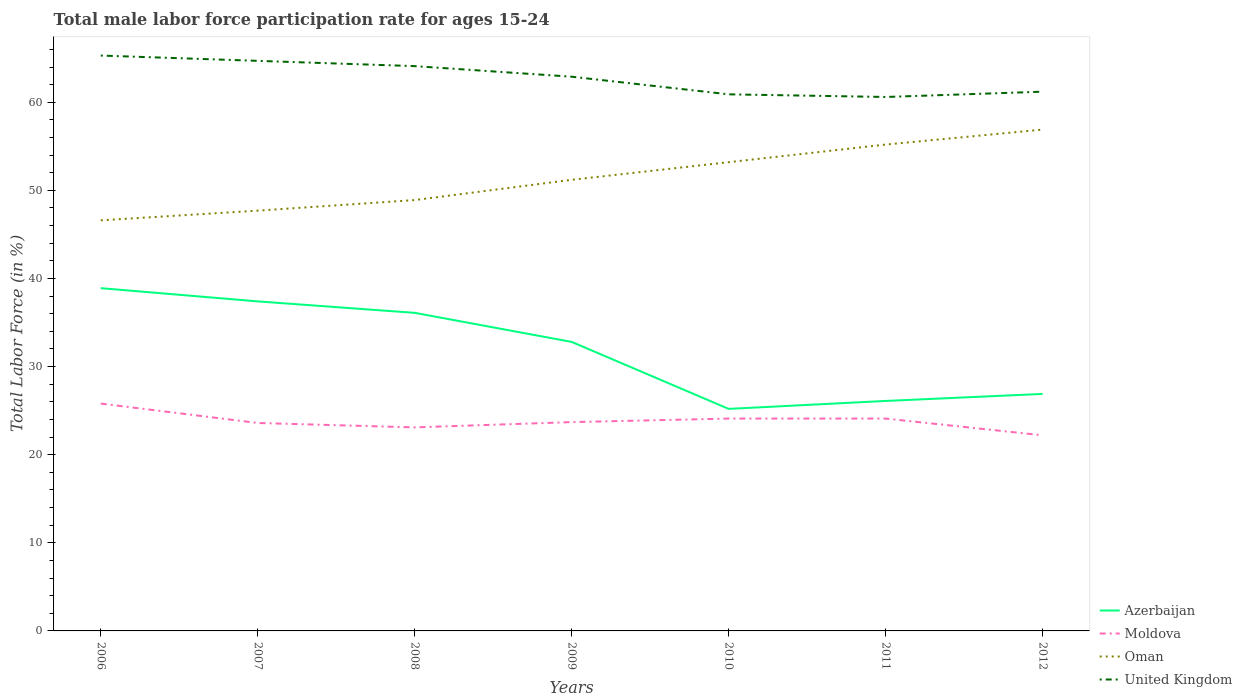How many different coloured lines are there?
Offer a terse response. 4. Does the line corresponding to Oman intersect with the line corresponding to United Kingdom?
Your response must be concise. No. Is the number of lines equal to the number of legend labels?
Offer a very short reply. Yes. Across all years, what is the maximum male labor force participation rate in Moldova?
Give a very brief answer. 22.2. What is the total male labor force participation rate in United Kingdom in the graph?
Offer a terse response. -0.6. What is the difference between the highest and the second highest male labor force participation rate in Oman?
Your answer should be very brief. 10.3. Is the male labor force participation rate in Moldova strictly greater than the male labor force participation rate in United Kingdom over the years?
Ensure brevity in your answer.  Yes. How many lines are there?
Provide a succinct answer. 4. What is the difference between two consecutive major ticks on the Y-axis?
Provide a succinct answer. 10. Does the graph contain any zero values?
Provide a short and direct response. No. Does the graph contain grids?
Keep it short and to the point. No. What is the title of the graph?
Provide a short and direct response. Total male labor force participation rate for ages 15-24. What is the Total Labor Force (in %) of Azerbaijan in 2006?
Ensure brevity in your answer.  38.9. What is the Total Labor Force (in %) of Moldova in 2006?
Make the answer very short. 25.8. What is the Total Labor Force (in %) in Oman in 2006?
Keep it short and to the point. 46.6. What is the Total Labor Force (in %) of United Kingdom in 2006?
Your answer should be compact. 65.3. What is the Total Labor Force (in %) in Azerbaijan in 2007?
Your answer should be compact. 37.4. What is the Total Labor Force (in %) in Moldova in 2007?
Make the answer very short. 23.6. What is the Total Labor Force (in %) in Oman in 2007?
Keep it short and to the point. 47.7. What is the Total Labor Force (in %) in United Kingdom in 2007?
Keep it short and to the point. 64.7. What is the Total Labor Force (in %) in Azerbaijan in 2008?
Your answer should be compact. 36.1. What is the Total Labor Force (in %) of Moldova in 2008?
Ensure brevity in your answer.  23.1. What is the Total Labor Force (in %) of Oman in 2008?
Keep it short and to the point. 48.9. What is the Total Labor Force (in %) in United Kingdom in 2008?
Offer a terse response. 64.1. What is the Total Labor Force (in %) in Azerbaijan in 2009?
Offer a very short reply. 32.8. What is the Total Labor Force (in %) in Moldova in 2009?
Give a very brief answer. 23.7. What is the Total Labor Force (in %) in Oman in 2009?
Provide a short and direct response. 51.2. What is the Total Labor Force (in %) of United Kingdom in 2009?
Keep it short and to the point. 62.9. What is the Total Labor Force (in %) of Azerbaijan in 2010?
Your response must be concise. 25.2. What is the Total Labor Force (in %) of Moldova in 2010?
Offer a terse response. 24.1. What is the Total Labor Force (in %) in Oman in 2010?
Keep it short and to the point. 53.2. What is the Total Labor Force (in %) in United Kingdom in 2010?
Offer a terse response. 60.9. What is the Total Labor Force (in %) of Azerbaijan in 2011?
Give a very brief answer. 26.1. What is the Total Labor Force (in %) of Moldova in 2011?
Make the answer very short. 24.1. What is the Total Labor Force (in %) of Oman in 2011?
Offer a terse response. 55.2. What is the Total Labor Force (in %) of United Kingdom in 2011?
Make the answer very short. 60.6. What is the Total Labor Force (in %) of Azerbaijan in 2012?
Keep it short and to the point. 26.9. What is the Total Labor Force (in %) in Moldova in 2012?
Keep it short and to the point. 22.2. What is the Total Labor Force (in %) in Oman in 2012?
Provide a short and direct response. 56.9. What is the Total Labor Force (in %) of United Kingdom in 2012?
Your answer should be very brief. 61.2. Across all years, what is the maximum Total Labor Force (in %) of Azerbaijan?
Offer a very short reply. 38.9. Across all years, what is the maximum Total Labor Force (in %) in Moldova?
Ensure brevity in your answer.  25.8. Across all years, what is the maximum Total Labor Force (in %) in Oman?
Keep it short and to the point. 56.9. Across all years, what is the maximum Total Labor Force (in %) in United Kingdom?
Ensure brevity in your answer.  65.3. Across all years, what is the minimum Total Labor Force (in %) in Azerbaijan?
Give a very brief answer. 25.2. Across all years, what is the minimum Total Labor Force (in %) of Moldova?
Ensure brevity in your answer.  22.2. Across all years, what is the minimum Total Labor Force (in %) of Oman?
Provide a succinct answer. 46.6. Across all years, what is the minimum Total Labor Force (in %) in United Kingdom?
Provide a short and direct response. 60.6. What is the total Total Labor Force (in %) of Azerbaijan in the graph?
Provide a succinct answer. 223.4. What is the total Total Labor Force (in %) in Moldova in the graph?
Give a very brief answer. 166.6. What is the total Total Labor Force (in %) of Oman in the graph?
Make the answer very short. 359.7. What is the total Total Labor Force (in %) in United Kingdom in the graph?
Your answer should be very brief. 439.7. What is the difference between the Total Labor Force (in %) of Azerbaijan in 2006 and that in 2007?
Offer a terse response. 1.5. What is the difference between the Total Labor Force (in %) in Moldova in 2006 and that in 2007?
Provide a succinct answer. 2.2. What is the difference between the Total Labor Force (in %) in Oman in 2006 and that in 2007?
Your response must be concise. -1.1. What is the difference between the Total Labor Force (in %) of United Kingdom in 2006 and that in 2007?
Your answer should be compact. 0.6. What is the difference between the Total Labor Force (in %) in Moldova in 2006 and that in 2008?
Your response must be concise. 2.7. What is the difference between the Total Labor Force (in %) in Oman in 2006 and that in 2008?
Your answer should be compact. -2.3. What is the difference between the Total Labor Force (in %) of Moldova in 2006 and that in 2009?
Your answer should be compact. 2.1. What is the difference between the Total Labor Force (in %) of Oman in 2006 and that in 2009?
Offer a very short reply. -4.6. What is the difference between the Total Labor Force (in %) in United Kingdom in 2006 and that in 2009?
Give a very brief answer. 2.4. What is the difference between the Total Labor Force (in %) in Azerbaijan in 2006 and that in 2010?
Give a very brief answer. 13.7. What is the difference between the Total Labor Force (in %) of Moldova in 2006 and that in 2010?
Offer a terse response. 1.7. What is the difference between the Total Labor Force (in %) of Oman in 2006 and that in 2011?
Offer a very short reply. -8.6. What is the difference between the Total Labor Force (in %) of Azerbaijan in 2006 and that in 2012?
Make the answer very short. 12. What is the difference between the Total Labor Force (in %) of Moldova in 2006 and that in 2012?
Your answer should be compact. 3.6. What is the difference between the Total Labor Force (in %) in Moldova in 2007 and that in 2008?
Offer a very short reply. 0.5. What is the difference between the Total Labor Force (in %) of United Kingdom in 2007 and that in 2008?
Keep it short and to the point. 0.6. What is the difference between the Total Labor Force (in %) of Oman in 2007 and that in 2009?
Keep it short and to the point. -3.5. What is the difference between the Total Labor Force (in %) of United Kingdom in 2007 and that in 2009?
Keep it short and to the point. 1.8. What is the difference between the Total Labor Force (in %) in United Kingdom in 2007 and that in 2010?
Provide a short and direct response. 3.8. What is the difference between the Total Labor Force (in %) of Oman in 2007 and that in 2011?
Make the answer very short. -7.5. What is the difference between the Total Labor Force (in %) of Oman in 2007 and that in 2012?
Provide a succinct answer. -9.2. What is the difference between the Total Labor Force (in %) of Oman in 2008 and that in 2009?
Offer a very short reply. -2.3. What is the difference between the Total Labor Force (in %) of United Kingdom in 2008 and that in 2010?
Keep it short and to the point. 3.2. What is the difference between the Total Labor Force (in %) of Azerbaijan in 2008 and that in 2011?
Make the answer very short. 10. What is the difference between the Total Labor Force (in %) of United Kingdom in 2008 and that in 2011?
Offer a very short reply. 3.5. What is the difference between the Total Labor Force (in %) of Azerbaijan in 2009 and that in 2010?
Keep it short and to the point. 7.6. What is the difference between the Total Labor Force (in %) of Moldova in 2009 and that in 2010?
Make the answer very short. -0.4. What is the difference between the Total Labor Force (in %) in Azerbaijan in 2009 and that in 2011?
Keep it short and to the point. 6.7. What is the difference between the Total Labor Force (in %) in Oman in 2009 and that in 2011?
Keep it short and to the point. -4. What is the difference between the Total Labor Force (in %) in Oman in 2009 and that in 2012?
Your response must be concise. -5.7. What is the difference between the Total Labor Force (in %) of United Kingdom in 2009 and that in 2012?
Provide a short and direct response. 1.7. What is the difference between the Total Labor Force (in %) of Moldova in 2010 and that in 2011?
Provide a succinct answer. 0. What is the difference between the Total Labor Force (in %) of Oman in 2010 and that in 2011?
Offer a very short reply. -2. What is the difference between the Total Labor Force (in %) in United Kingdom in 2010 and that in 2011?
Make the answer very short. 0.3. What is the difference between the Total Labor Force (in %) in United Kingdom in 2010 and that in 2012?
Provide a short and direct response. -0.3. What is the difference between the Total Labor Force (in %) in Moldova in 2011 and that in 2012?
Your answer should be compact. 1.9. What is the difference between the Total Labor Force (in %) of Azerbaijan in 2006 and the Total Labor Force (in %) of Moldova in 2007?
Your response must be concise. 15.3. What is the difference between the Total Labor Force (in %) of Azerbaijan in 2006 and the Total Labor Force (in %) of United Kingdom in 2007?
Make the answer very short. -25.8. What is the difference between the Total Labor Force (in %) in Moldova in 2006 and the Total Labor Force (in %) in Oman in 2007?
Your response must be concise. -21.9. What is the difference between the Total Labor Force (in %) of Moldova in 2006 and the Total Labor Force (in %) of United Kingdom in 2007?
Provide a succinct answer. -38.9. What is the difference between the Total Labor Force (in %) in Oman in 2006 and the Total Labor Force (in %) in United Kingdom in 2007?
Provide a succinct answer. -18.1. What is the difference between the Total Labor Force (in %) in Azerbaijan in 2006 and the Total Labor Force (in %) in Moldova in 2008?
Your answer should be compact. 15.8. What is the difference between the Total Labor Force (in %) in Azerbaijan in 2006 and the Total Labor Force (in %) in Oman in 2008?
Ensure brevity in your answer.  -10. What is the difference between the Total Labor Force (in %) in Azerbaijan in 2006 and the Total Labor Force (in %) in United Kingdom in 2008?
Your answer should be compact. -25.2. What is the difference between the Total Labor Force (in %) in Moldova in 2006 and the Total Labor Force (in %) in Oman in 2008?
Offer a very short reply. -23.1. What is the difference between the Total Labor Force (in %) of Moldova in 2006 and the Total Labor Force (in %) of United Kingdom in 2008?
Offer a very short reply. -38.3. What is the difference between the Total Labor Force (in %) in Oman in 2006 and the Total Labor Force (in %) in United Kingdom in 2008?
Make the answer very short. -17.5. What is the difference between the Total Labor Force (in %) of Azerbaijan in 2006 and the Total Labor Force (in %) of Moldova in 2009?
Your answer should be very brief. 15.2. What is the difference between the Total Labor Force (in %) in Azerbaijan in 2006 and the Total Labor Force (in %) in United Kingdom in 2009?
Offer a very short reply. -24. What is the difference between the Total Labor Force (in %) of Moldova in 2006 and the Total Labor Force (in %) of Oman in 2009?
Give a very brief answer. -25.4. What is the difference between the Total Labor Force (in %) of Moldova in 2006 and the Total Labor Force (in %) of United Kingdom in 2009?
Ensure brevity in your answer.  -37.1. What is the difference between the Total Labor Force (in %) of Oman in 2006 and the Total Labor Force (in %) of United Kingdom in 2009?
Your answer should be very brief. -16.3. What is the difference between the Total Labor Force (in %) of Azerbaijan in 2006 and the Total Labor Force (in %) of Moldova in 2010?
Keep it short and to the point. 14.8. What is the difference between the Total Labor Force (in %) of Azerbaijan in 2006 and the Total Labor Force (in %) of Oman in 2010?
Offer a terse response. -14.3. What is the difference between the Total Labor Force (in %) of Moldova in 2006 and the Total Labor Force (in %) of Oman in 2010?
Offer a very short reply. -27.4. What is the difference between the Total Labor Force (in %) of Moldova in 2006 and the Total Labor Force (in %) of United Kingdom in 2010?
Provide a succinct answer. -35.1. What is the difference between the Total Labor Force (in %) of Oman in 2006 and the Total Labor Force (in %) of United Kingdom in 2010?
Provide a succinct answer. -14.3. What is the difference between the Total Labor Force (in %) of Azerbaijan in 2006 and the Total Labor Force (in %) of Moldova in 2011?
Make the answer very short. 14.8. What is the difference between the Total Labor Force (in %) in Azerbaijan in 2006 and the Total Labor Force (in %) in Oman in 2011?
Give a very brief answer. -16.3. What is the difference between the Total Labor Force (in %) in Azerbaijan in 2006 and the Total Labor Force (in %) in United Kingdom in 2011?
Your response must be concise. -21.7. What is the difference between the Total Labor Force (in %) of Moldova in 2006 and the Total Labor Force (in %) of Oman in 2011?
Offer a very short reply. -29.4. What is the difference between the Total Labor Force (in %) of Moldova in 2006 and the Total Labor Force (in %) of United Kingdom in 2011?
Make the answer very short. -34.8. What is the difference between the Total Labor Force (in %) of Oman in 2006 and the Total Labor Force (in %) of United Kingdom in 2011?
Your answer should be very brief. -14. What is the difference between the Total Labor Force (in %) of Azerbaijan in 2006 and the Total Labor Force (in %) of United Kingdom in 2012?
Your response must be concise. -22.3. What is the difference between the Total Labor Force (in %) of Moldova in 2006 and the Total Labor Force (in %) of Oman in 2012?
Provide a succinct answer. -31.1. What is the difference between the Total Labor Force (in %) of Moldova in 2006 and the Total Labor Force (in %) of United Kingdom in 2012?
Provide a short and direct response. -35.4. What is the difference between the Total Labor Force (in %) in Oman in 2006 and the Total Labor Force (in %) in United Kingdom in 2012?
Your answer should be very brief. -14.6. What is the difference between the Total Labor Force (in %) in Azerbaijan in 2007 and the Total Labor Force (in %) in United Kingdom in 2008?
Provide a short and direct response. -26.7. What is the difference between the Total Labor Force (in %) in Moldova in 2007 and the Total Labor Force (in %) in Oman in 2008?
Give a very brief answer. -25.3. What is the difference between the Total Labor Force (in %) in Moldova in 2007 and the Total Labor Force (in %) in United Kingdom in 2008?
Keep it short and to the point. -40.5. What is the difference between the Total Labor Force (in %) of Oman in 2007 and the Total Labor Force (in %) of United Kingdom in 2008?
Give a very brief answer. -16.4. What is the difference between the Total Labor Force (in %) in Azerbaijan in 2007 and the Total Labor Force (in %) in Moldova in 2009?
Offer a terse response. 13.7. What is the difference between the Total Labor Force (in %) of Azerbaijan in 2007 and the Total Labor Force (in %) of United Kingdom in 2009?
Your answer should be compact. -25.5. What is the difference between the Total Labor Force (in %) of Moldova in 2007 and the Total Labor Force (in %) of Oman in 2009?
Your response must be concise. -27.6. What is the difference between the Total Labor Force (in %) of Moldova in 2007 and the Total Labor Force (in %) of United Kingdom in 2009?
Provide a short and direct response. -39.3. What is the difference between the Total Labor Force (in %) of Oman in 2007 and the Total Labor Force (in %) of United Kingdom in 2009?
Your answer should be very brief. -15.2. What is the difference between the Total Labor Force (in %) in Azerbaijan in 2007 and the Total Labor Force (in %) in Moldova in 2010?
Ensure brevity in your answer.  13.3. What is the difference between the Total Labor Force (in %) in Azerbaijan in 2007 and the Total Labor Force (in %) in Oman in 2010?
Your answer should be very brief. -15.8. What is the difference between the Total Labor Force (in %) of Azerbaijan in 2007 and the Total Labor Force (in %) of United Kingdom in 2010?
Give a very brief answer. -23.5. What is the difference between the Total Labor Force (in %) in Moldova in 2007 and the Total Labor Force (in %) in Oman in 2010?
Keep it short and to the point. -29.6. What is the difference between the Total Labor Force (in %) in Moldova in 2007 and the Total Labor Force (in %) in United Kingdom in 2010?
Your answer should be compact. -37.3. What is the difference between the Total Labor Force (in %) in Oman in 2007 and the Total Labor Force (in %) in United Kingdom in 2010?
Provide a succinct answer. -13.2. What is the difference between the Total Labor Force (in %) of Azerbaijan in 2007 and the Total Labor Force (in %) of Moldova in 2011?
Make the answer very short. 13.3. What is the difference between the Total Labor Force (in %) of Azerbaijan in 2007 and the Total Labor Force (in %) of Oman in 2011?
Provide a succinct answer. -17.8. What is the difference between the Total Labor Force (in %) in Azerbaijan in 2007 and the Total Labor Force (in %) in United Kingdom in 2011?
Offer a terse response. -23.2. What is the difference between the Total Labor Force (in %) in Moldova in 2007 and the Total Labor Force (in %) in Oman in 2011?
Make the answer very short. -31.6. What is the difference between the Total Labor Force (in %) of Moldova in 2007 and the Total Labor Force (in %) of United Kingdom in 2011?
Keep it short and to the point. -37. What is the difference between the Total Labor Force (in %) of Oman in 2007 and the Total Labor Force (in %) of United Kingdom in 2011?
Ensure brevity in your answer.  -12.9. What is the difference between the Total Labor Force (in %) in Azerbaijan in 2007 and the Total Labor Force (in %) in Oman in 2012?
Your answer should be very brief. -19.5. What is the difference between the Total Labor Force (in %) in Azerbaijan in 2007 and the Total Labor Force (in %) in United Kingdom in 2012?
Keep it short and to the point. -23.8. What is the difference between the Total Labor Force (in %) in Moldova in 2007 and the Total Labor Force (in %) in Oman in 2012?
Give a very brief answer. -33.3. What is the difference between the Total Labor Force (in %) in Moldova in 2007 and the Total Labor Force (in %) in United Kingdom in 2012?
Your answer should be compact. -37.6. What is the difference between the Total Labor Force (in %) in Oman in 2007 and the Total Labor Force (in %) in United Kingdom in 2012?
Give a very brief answer. -13.5. What is the difference between the Total Labor Force (in %) in Azerbaijan in 2008 and the Total Labor Force (in %) in Oman in 2009?
Your response must be concise. -15.1. What is the difference between the Total Labor Force (in %) in Azerbaijan in 2008 and the Total Labor Force (in %) in United Kingdom in 2009?
Provide a short and direct response. -26.8. What is the difference between the Total Labor Force (in %) in Moldova in 2008 and the Total Labor Force (in %) in Oman in 2009?
Your answer should be very brief. -28.1. What is the difference between the Total Labor Force (in %) in Moldova in 2008 and the Total Labor Force (in %) in United Kingdom in 2009?
Keep it short and to the point. -39.8. What is the difference between the Total Labor Force (in %) of Oman in 2008 and the Total Labor Force (in %) of United Kingdom in 2009?
Your answer should be compact. -14. What is the difference between the Total Labor Force (in %) in Azerbaijan in 2008 and the Total Labor Force (in %) in Oman in 2010?
Your answer should be very brief. -17.1. What is the difference between the Total Labor Force (in %) in Azerbaijan in 2008 and the Total Labor Force (in %) in United Kingdom in 2010?
Provide a short and direct response. -24.8. What is the difference between the Total Labor Force (in %) in Moldova in 2008 and the Total Labor Force (in %) in Oman in 2010?
Offer a terse response. -30.1. What is the difference between the Total Labor Force (in %) in Moldova in 2008 and the Total Labor Force (in %) in United Kingdom in 2010?
Give a very brief answer. -37.8. What is the difference between the Total Labor Force (in %) in Azerbaijan in 2008 and the Total Labor Force (in %) in Oman in 2011?
Give a very brief answer. -19.1. What is the difference between the Total Labor Force (in %) in Azerbaijan in 2008 and the Total Labor Force (in %) in United Kingdom in 2011?
Offer a terse response. -24.5. What is the difference between the Total Labor Force (in %) in Moldova in 2008 and the Total Labor Force (in %) in Oman in 2011?
Keep it short and to the point. -32.1. What is the difference between the Total Labor Force (in %) of Moldova in 2008 and the Total Labor Force (in %) of United Kingdom in 2011?
Make the answer very short. -37.5. What is the difference between the Total Labor Force (in %) of Oman in 2008 and the Total Labor Force (in %) of United Kingdom in 2011?
Make the answer very short. -11.7. What is the difference between the Total Labor Force (in %) in Azerbaijan in 2008 and the Total Labor Force (in %) in Moldova in 2012?
Provide a short and direct response. 13.9. What is the difference between the Total Labor Force (in %) of Azerbaijan in 2008 and the Total Labor Force (in %) of Oman in 2012?
Provide a short and direct response. -20.8. What is the difference between the Total Labor Force (in %) in Azerbaijan in 2008 and the Total Labor Force (in %) in United Kingdom in 2012?
Your response must be concise. -25.1. What is the difference between the Total Labor Force (in %) of Moldova in 2008 and the Total Labor Force (in %) of Oman in 2012?
Your response must be concise. -33.8. What is the difference between the Total Labor Force (in %) of Moldova in 2008 and the Total Labor Force (in %) of United Kingdom in 2012?
Make the answer very short. -38.1. What is the difference between the Total Labor Force (in %) of Azerbaijan in 2009 and the Total Labor Force (in %) of Oman in 2010?
Give a very brief answer. -20.4. What is the difference between the Total Labor Force (in %) of Azerbaijan in 2009 and the Total Labor Force (in %) of United Kingdom in 2010?
Provide a short and direct response. -28.1. What is the difference between the Total Labor Force (in %) of Moldova in 2009 and the Total Labor Force (in %) of Oman in 2010?
Ensure brevity in your answer.  -29.5. What is the difference between the Total Labor Force (in %) in Moldova in 2009 and the Total Labor Force (in %) in United Kingdom in 2010?
Ensure brevity in your answer.  -37.2. What is the difference between the Total Labor Force (in %) of Oman in 2009 and the Total Labor Force (in %) of United Kingdom in 2010?
Ensure brevity in your answer.  -9.7. What is the difference between the Total Labor Force (in %) of Azerbaijan in 2009 and the Total Labor Force (in %) of Oman in 2011?
Your response must be concise. -22.4. What is the difference between the Total Labor Force (in %) in Azerbaijan in 2009 and the Total Labor Force (in %) in United Kingdom in 2011?
Your response must be concise. -27.8. What is the difference between the Total Labor Force (in %) in Moldova in 2009 and the Total Labor Force (in %) in Oman in 2011?
Provide a succinct answer. -31.5. What is the difference between the Total Labor Force (in %) in Moldova in 2009 and the Total Labor Force (in %) in United Kingdom in 2011?
Your answer should be compact. -36.9. What is the difference between the Total Labor Force (in %) in Oman in 2009 and the Total Labor Force (in %) in United Kingdom in 2011?
Your response must be concise. -9.4. What is the difference between the Total Labor Force (in %) in Azerbaijan in 2009 and the Total Labor Force (in %) in Oman in 2012?
Your answer should be compact. -24.1. What is the difference between the Total Labor Force (in %) of Azerbaijan in 2009 and the Total Labor Force (in %) of United Kingdom in 2012?
Make the answer very short. -28.4. What is the difference between the Total Labor Force (in %) of Moldova in 2009 and the Total Labor Force (in %) of Oman in 2012?
Provide a short and direct response. -33.2. What is the difference between the Total Labor Force (in %) in Moldova in 2009 and the Total Labor Force (in %) in United Kingdom in 2012?
Give a very brief answer. -37.5. What is the difference between the Total Labor Force (in %) of Oman in 2009 and the Total Labor Force (in %) of United Kingdom in 2012?
Your response must be concise. -10. What is the difference between the Total Labor Force (in %) of Azerbaijan in 2010 and the Total Labor Force (in %) of Moldova in 2011?
Keep it short and to the point. 1.1. What is the difference between the Total Labor Force (in %) in Azerbaijan in 2010 and the Total Labor Force (in %) in United Kingdom in 2011?
Offer a very short reply. -35.4. What is the difference between the Total Labor Force (in %) of Moldova in 2010 and the Total Labor Force (in %) of Oman in 2011?
Ensure brevity in your answer.  -31.1. What is the difference between the Total Labor Force (in %) of Moldova in 2010 and the Total Labor Force (in %) of United Kingdom in 2011?
Your answer should be compact. -36.5. What is the difference between the Total Labor Force (in %) in Oman in 2010 and the Total Labor Force (in %) in United Kingdom in 2011?
Give a very brief answer. -7.4. What is the difference between the Total Labor Force (in %) of Azerbaijan in 2010 and the Total Labor Force (in %) of Moldova in 2012?
Make the answer very short. 3. What is the difference between the Total Labor Force (in %) in Azerbaijan in 2010 and the Total Labor Force (in %) in Oman in 2012?
Provide a short and direct response. -31.7. What is the difference between the Total Labor Force (in %) in Azerbaijan in 2010 and the Total Labor Force (in %) in United Kingdom in 2012?
Keep it short and to the point. -36. What is the difference between the Total Labor Force (in %) in Moldova in 2010 and the Total Labor Force (in %) in Oman in 2012?
Offer a terse response. -32.8. What is the difference between the Total Labor Force (in %) of Moldova in 2010 and the Total Labor Force (in %) of United Kingdom in 2012?
Give a very brief answer. -37.1. What is the difference between the Total Labor Force (in %) of Azerbaijan in 2011 and the Total Labor Force (in %) of Moldova in 2012?
Your response must be concise. 3.9. What is the difference between the Total Labor Force (in %) in Azerbaijan in 2011 and the Total Labor Force (in %) in Oman in 2012?
Keep it short and to the point. -30.8. What is the difference between the Total Labor Force (in %) in Azerbaijan in 2011 and the Total Labor Force (in %) in United Kingdom in 2012?
Provide a short and direct response. -35.1. What is the difference between the Total Labor Force (in %) in Moldova in 2011 and the Total Labor Force (in %) in Oman in 2012?
Offer a terse response. -32.8. What is the difference between the Total Labor Force (in %) of Moldova in 2011 and the Total Labor Force (in %) of United Kingdom in 2012?
Give a very brief answer. -37.1. What is the difference between the Total Labor Force (in %) of Oman in 2011 and the Total Labor Force (in %) of United Kingdom in 2012?
Offer a terse response. -6. What is the average Total Labor Force (in %) in Azerbaijan per year?
Your answer should be very brief. 31.91. What is the average Total Labor Force (in %) of Moldova per year?
Your answer should be compact. 23.8. What is the average Total Labor Force (in %) in Oman per year?
Give a very brief answer. 51.39. What is the average Total Labor Force (in %) in United Kingdom per year?
Keep it short and to the point. 62.81. In the year 2006, what is the difference between the Total Labor Force (in %) of Azerbaijan and Total Labor Force (in %) of Moldova?
Your answer should be very brief. 13.1. In the year 2006, what is the difference between the Total Labor Force (in %) of Azerbaijan and Total Labor Force (in %) of Oman?
Make the answer very short. -7.7. In the year 2006, what is the difference between the Total Labor Force (in %) of Azerbaijan and Total Labor Force (in %) of United Kingdom?
Offer a terse response. -26.4. In the year 2006, what is the difference between the Total Labor Force (in %) in Moldova and Total Labor Force (in %) in Oman?
Keep it short and to the point. -20.8. In the year 2006, what is the difference between the Total Labor Force (in %) of Moldova and Total Labor Force (in %) of United Kingdom?
Offer a very short reply. -39.5. In the year 2006, what is the difference between the Total Labor Force (in %) in Oman and Total Labor Force (in %) in United Kingdom?
Your answer should be compact. -18.7. In the year 2007, what is the difference between the Total Labor Force (in %) of Azerbaijan and Total Labor Force (in %) of United Kingdom?
Provide a short and direct response. -27.3. In the year 2007, what is the difference between the Total Labor Force (in %) of Moldova and Total Labor Force (in %) of Oman?
Provide a succinct answer. -24.1. In the year 2007, what is the difference between the Total Labor Force (in %) of Moldova and Total Labor Force (in %) of United Kingdom?
Your response must be concise. -41.1. In the year 2007, what is the difference between the Total Labor Force (in %) in Oman and Total Labor Force (in %) in United Kingdom?
Ensure brevity in your answer.  -17. In the year 2008, what is the difference between the Total Labor Force (in %) of Azerbaijan and Total Labor Force (in %) of Moldova?
Make the answer very short. 13. In the year 2008, what is the difference between the Total Labor Force (in %) in Azerbaijan and Total Labor Force (in %) in United Kingdom?
Your response must be concise. -28. In the year 2008, what is the difference between the Total Labor Force (in %) in Moldova and Total Labor Force (in %) in Oman?
Provide a succinct answer. -25.8. In the year 2008, what is the difference between the Total Labor Force (in %) of Moldova and Total Labor Force (in %) of United Kingdom?
Keep it short and to the point. -41. In the year 2008, what is the difference between the Total Labor Force (in %) of Oman and Total Labor Force (in %) of United Kingdom?
Offer a very short reply. -15.2. In the year 2009, what is the difference between the Total Labor Force (in %) in Azerbaijan and Total Labor Force (in %) in Oman?
Your answer should be very brief. -18.4. In the year 2009, what is the difference between the Total Labor Force (in %) of Azerbaijan and Total Labor Force (in %) of United Kingdom?
Offer a very short reply. -30.1. In the year 2009, what is the difference between the Total Labor Force (in %) of Moldova and Total Labor Force (in %) of Oman?
Your answer should be very brief. -27.5. In the year 2009, what is the difference between the Total Labor Force (in %) in Moldova and Total Labor Force (in %) in United Kingdom?
Give a very brief answer. -39.2. In the year 2009, what is the difference between the Total Labor Force (in %) of Oman and Total Labor Force (in %) of United Kingdom?
Offer a very short reply. -11.7. In the year 2010, what is the difference between the Total Labor Force (in %) of Azerbaijan and Total Labor Force (in %) of United Kingdom?
Make the answer very short. -35.7. In the year 2010, what is the difference between the Total Labor Force (in %) in Moldova and Total Labor Force (in %) in Oman?
Give a very brief answer. -29.1. In the year 2010, what is the difference between the Total Labor Force (in %) of Moldova and Total Labor Force (in %) of United Kingdom?
Keep it short and to the point. -36.8. In the year 2011, what is the difference between the Total Labor Force (in %) of Azerbaijan and Total Labor Force (in %) of Oman?
Your answer should be very brief. -29.1. In the year 2011, what is the difference between the Total Labor Force (in %) in Azerbaijan and Total Labor Force (in %) in United Kingdom?
Ensure brevity in your answer.  -34.5. In the year 2011, what is the difference between the Total Labor Force (in %) in Moldova and Total Labor Force (in %) in Oman?
Offer a terse response. -31.1. In the year 2011, what is the difference between the Total Labor Force (in %) of Moldova and Total Labor Force (in %) of United Kingdom?
Offer a terse response. -36.5. In the year 2012, what is the difference between the Total Labor Force (in %) of Azerbaijan and Total Labor Force (in %) of Moldova?
Offer a terse response. 4.7. In the year 2012, what is the difference between the Total Labor Force (in %) of Azerbaijan and Total Labor Force (in %) of Oman?
Your answer should be compact. -30. In the year 2012, what is the difference between the Total Labor Force (in %) of Azerbaijan and Total Labor Force (in %) of United Kingdom?
Ensure brevity in your answer.  -34.3. In the year 2012, what is the difference between the Total Labor Force (in %) of Moldova and Total Labor Force (in %) of Oman?
Offer a very short reply. -34.7. In the year 2012, what is the difference between the Total Labor Force (in %) of Moldova and Total Labor Force (in %) of United Kingdom?
Give a very brief answer. -39. In the year 2012, what is the difference between the Total Labor Force (in %) in Oman and Total Labor Force (in %) in United Kingdom?
Keep it short and to the point. -4.3. What is the ratio of the Total Labor Force (in %) in Azerbaijan in 2006 to that in 2007?
Your answer should be compact. 1.04. What is the ratio of the Total Labor Force (in %) in Moldova in 2006 to that in 2007?
Offer a terse response. 1.09. What is the ratio of the Total Labor Force (in %) of Oman in 2006 to that in 2007?
Give a very brief answer. 0.98. What is the ratio of the Total Labor Force (in %) in United Kingdom in 2006 to that in 2007?
Offer a terse response. 1.01. What is the ratio of the Total Labor Force (in %) in Azerbaijan in 2006 to that in 2008?
Your answer should be compact. 1.08. What is the ratio of the Total Labor Force (in %) of Moldova in 2006 to that in 2008?
Offer a very short reply. 1.12. What is the ratio of the Total Labor Force (in %) in Oman in 2006 to that in 2008?
Your answer should be compact. 0.95. What is the ratio of the Total Labor Force (in %) in United Kingdom in 2006 to that in 2008?
Your answer should be compact. 1.02. What is the ratio of the Total Labor Force (in %) in Azerbaijan in 2006 to that in 2009?
Your response must be concise. 1.19. What is the ratio of the Total Labor Force (in %) in Moldova in 2006 to that in 2009?
Make the answer very short. 1.09. What is the ratio of the Total Labor Force (in %) of Oman in 2006 to that in 2009?
Offer a terse response. 0.91. What is the ratio of the Total Labor Force (in %) of United Kingdom in 2006 to that in 2009?
Keep it short and to the point. 1.04. What is the ratio of the Total Labor Force (in %) of Azerbaijan in 2006 to that in 2010?
Provide a succinct answer. 1.54. What is the ratio of the Total Labor Force (in %) of Moldova in 2006 to that in 2010?
Your answer should be very brief. 1.07. What is the ratio of the Total Labor Force (in %) in Oman in 2006 to that in 2010?
Give a very brief answer. 0.88. What is the ratio of the Total Labor Force (in %) of United Kingdom in 2006 to that in 2010?
Make the answer very short. 1.07. What is the ratio of the Total Labor Force (in %) in Azerbaijan in 2006 to that in 2011?
Your answer should be compact. 1.49. What is the ratio of the Total Labor Force (in %) in Moldova in 2006 to that in 2011?
Give a very brief answer. 1.07. What is the ratio of the Total Labor Force (in %) of Oman in 2006 to that in 2011?
Provide a succinct answer. 0.84. What is the ratio of the Total Labor Force (in %) in United Kingdom in 2006 to that in 2011?
Ensure brevity in your answer.  1.08. What is the ratio of the Total Labor Force (in %) in Azerbaijan in 2006 to that in 2012?
Offer a very short reply. 1.45. What is the ratio of the Total Labor Force (in %) in Moldova in 2006 to that in 2012?
Your answer should be compact. 1.16. What is the ratio of the Total Labor Force (in %) of Oman in 2006 to that in 2012?
Provide a succinct answer. 0.82. What is the ratio of the Total Labor Force (in %) of United Kingdom in 2006 to that in 2012?
Give a very brief answer. 1.07. What is the ratio of the Total Labor Force (in %) in Azerbaijan in 2007 to that in 2008?
Your answer should be very brief. 1.04. What is the ratio of the Total Labor Force (in %) of Moldova in 2007 to that in 2008?
Provide a short and direct response. 1.02. What is the ratio of the Total Labor Force (in %) of Oman in 2007 to that in 2008?
Ensure brevity in your answer.  0.98. What is the ratio of the Total Labor Force (in %) of United Kingdom in 2007 to that in 2008?
Make the answer very short. 1.01. What is the ratio of the Total Labor Force (in %) in Azerbaijan in 2007 to that in 2009?
Offer a terse response. 1.14. What is the ratio of the Total Labor Force (in %) in Oman in 2007 to that in 2009?
Give a very brief answer. 0.93. What is the ratio of the Total Labor Force (in %) in United Kingdom in 2007 to that in 2009?
Provide a short and direct response. 1.03. What is the ratio of the Total Labor Force (in %) of Azerbaijan in 2007 to that in 2010?
Provide a short and direct response. 1.48. What is the ratio of the Total Labor Force (in %) of Moldova in 2007 to that in 2010?
Your answer should be very brief. 0.98. What is the ratio of the Total Labor Force (in %) of Oman in 2007 to that in 2010?
Your answer should be compact. 0.9. What is the ratio of the Total Labor Force (in %) in United Kingdom in 2007 to that in 2010?
Give a very brief answer. 1.06. What is the ratio of the Total Labor Force (in %) of Azerbaijan in 2007 to that in 2011?
Provide a succinct answer. 1.43. What is the ratio of the Total Labor Force (in %) in Moldova in 2007 to that in 2011?
Your answer should be compact. 0.98. What is the ratio of the Total Labor Force (in %) in Oman in 2007 to that in 2011?
Provide a succinct answer. 0.86. What is the ratio of the Total Labor Force (in %) of United Kingdom in 2007 to that in 2011?
Offer a very short reply. 1.07. What is the ratio of the Total Labor Force (in %) of Azerbaijan in 2007 to that in 2012?
Give a very brief answer. 1.39. What is the ratio of the Total Labor Force (in %) in Moldova in 2007 to that in 2012?
Keep it short and to the point. 1.06. What is the ratio of the Total Labor Force (in %) of Oman in 2007 to that in 2012?
Your response must be concise. 0.84. What is the ratio of the Total Labor Force (in %) of United Kingdom in 2007 to that in 2012?
Provide a short and direct response. 1.06. What is the ratio of the Total Labor Force (in %) of Azerbaijan in 2008 to that in 2009?
Offer a terse response. 1.1. What is the ratio of the Total Labor Force (in %) in Moldova in 2008 to that in 2009?
Make the answer very short. 0.97. What is the ratio of the Total Labor Force (in %) in Oman in 2008 to that in 2009?
Provide a succinct answer. 0.96. What is the ratio of the Total Labor Force (in %) of United Kingdom in 2008 to that in 2009?
Give a very brief answer. 1.02. What is the ratio of the Total Labor Force (in %) of Azerbaijan in 2008 to that in 2010?
Your answer should be very brief. 1.43. What is the ratio of the Total Labor Force (in %) of Moldova in 2008 to that in 2010?
Provide a short and direct response. 0.96. What is the ratio of the Total Labor Force (in %) of Oman in 2008 to that in 2010?
Offer a very short reply. 0.92. What is the ratio of the Total Labor Force (in %) in United Kingdom in 2008 to that in 2010?
Offer a very short reply. 1.05. What is the ratio of the Total Labor Force (in %) in Azerbaijan in 2008 to that in 2011?
Your response must be concise. 1.38. What is the ratio of the Total Labor Force (in %) in Moldova in 2008 to that in 2011?
Make the answer very short. 0.96. What is the ratio of the Total Labor Force (in %) in Oman in 2008 to that in 2011?
Keep it short and to the point. 0.89. What is the ratio of the Total Labor Force (in %) in United Kingdom in 2008 to that in 2011?
Your answer should be very brief. 1.06. What is the ratio of the Total Labor Force (in %) in Azerbaijan in 2008 to that in 2012?
Your response must be concise. 1.34. What is the ratio of the Total Labor Force (in %) of Moldova in 2008 to that in 2012?
Keep it short and to the point. 1.04. What is the ratio of the Total Labor Force (in %) of Oman in 2008 to that in 2012?
Your answer should be compact. 0.86. What is the ratio of the Total Labor Force (in %) of United Kingdom in 2008 to that in 2012?
Keep it short and to the point. 1.05. What is the ratio of the Total Labor Force (in %) of Azerbaijan in 2009 to that in 2010?
Offer a terse response. 1.3. What is the ratio of the Total Labor Force (in %) in Moldova in 2009 to that in 2010?
Your answer should be very brief. 0.98. What is the ratio of the Total Labor Force (in %) of Oman in 2009 to that in 2010?
Offer a terse response. 0.96. What is the ratio of the Total Labor Force (in %) in United Kingdom in 2009 to that in 2010?
Provide a succinct answer. 1.03. What is the ratio of the Total Labor Force (in %) in Azerbaijan in 2009 to that in 2011?
Provide a short and direct response. 1.26. What is the ratio of the Total Labor Force (in %) of Moldova in 2009 to that in 2011?
Offer a very short reply. 0.98. What is the ratio of the Total Labor Force (in %) in Oman in 2009 to that in 2011?
Your answer should be compact. 0.93. What is the ratio of the Total Labor Force (in %) of United Kingdom in 2009 to that in 2011?
Your response must be concise. 1.04. What is the ratio of the Total Labor Force (in %) of Azerbaijan in 2009 to that in 2012?
Ensure brevity in your answer.  1.22. What is the ratio of the Total Labor Force (in %) in Moldova in 2009 to that in 2012?
Your answer should be compact. 1.07. What is the ratio of the Total Labor Force (in %) of Oman in 2009 to that in 2012?
Your answer should be very brief. 0.9. What is the ratio of the Total Labor Force (in %) in United Kingdom in 2009 to that in 2012?
Ensure brevity in your answer.  1.03. What is the ratio of the Total Labor Force (in %) of Azerbaijan in 2010 to that in 2011?
Make the answer very short. 0.97. What is the ratio of the Total Labor Force (in %) in Oman in 2010 to that in 2011?
Offer a terse response. 0.96. What is the ratio of the Total Labor Force (in %) in Azerbaijan in 2010 to that in 2012?
Your response must be concise. 0.94. What is the ratio of the Total Labor Force (in %) of Moldova in 2010 to that in 2012?
Provide a succinct answer. 1.09. What is the ratio of the Total Labor Force (in %) in Oman in 2010 to that in 2012?
Ensure brevity in your answer.  0.94. What is the ratio of the Total Labor Force (in %) in United Kingdom in 2010 to that in 2012?
Provide a short and direct response. 1. What is the ratio of the Total Labor Force (in %) of Azerbaijan in 2011 to that in 2012?
Make the answer very short. 0.97. What is the ratio of the Total Labor Force (in %) of Moldova in 2011 to that in 2012?
Keep it short and to the point. 1.09. What is the ratio of the Total Labor Force (in %) in Oman in 2011 to that in 2012?
Make the answer very short. 0.97. What is the ratio of the Total Labor Force (in %) in United Kingdom in 2011 to that in 2012?
Ensure brevity in your answer.  0.99. What is the difference between the highest and the lowest Total Labor Force (in %) in Azerbaijan?
Provide a succinct answer. 13.7. What is the difference between the highest and the lowest Total Labor Force (in %) in Moldova?
Your response must be concise. 3.6. What is the difference between the highest and the lowest Total Labor Force (in %) in Oman?
Ensure brevity in your answer.  10.3. 